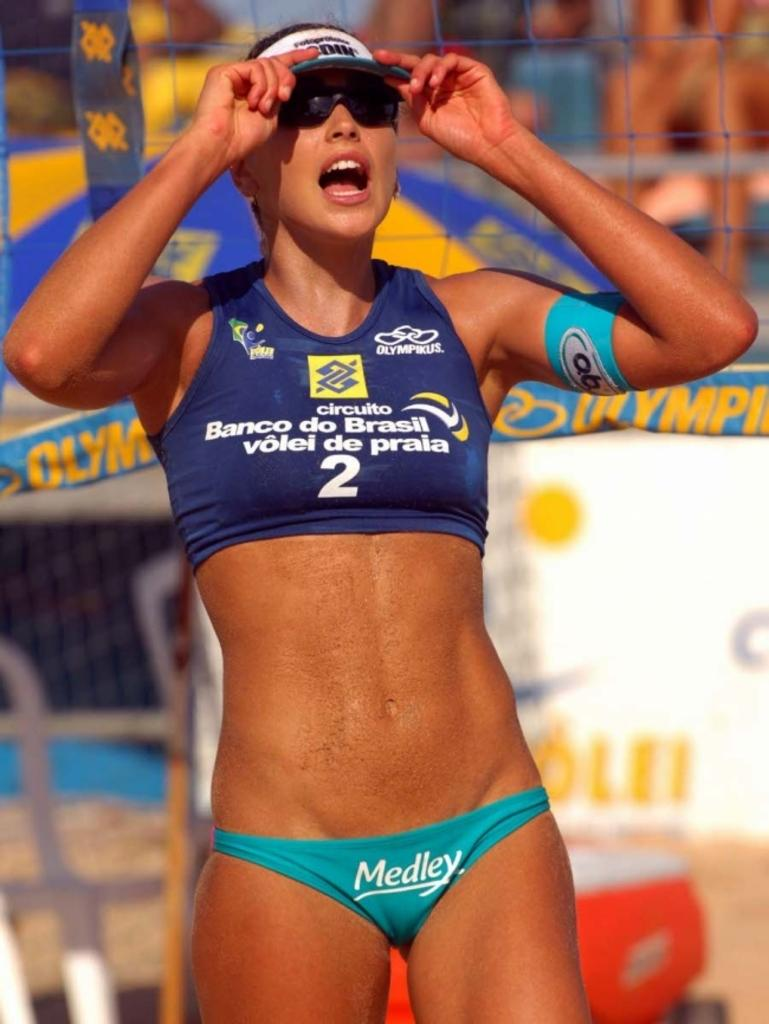Who is the main subject in the image? There is a woman in the image. What is the woman wearing on her face? The woman is wearing goggles. What is the woman wearing on her head? The woman is wearing a cap. What can be seen in the background of the image? There is a net, banners, people, and some objects in the background of the image. How many ants can be seen on the woman's cap in the image? There are no ants visible on the woman's cap in the image. What day of the week is the visitor expected to arrive in the image? There is no visitor mentioned or depicted in the image, so it is not possible to determine the day of the week they might arrive. 